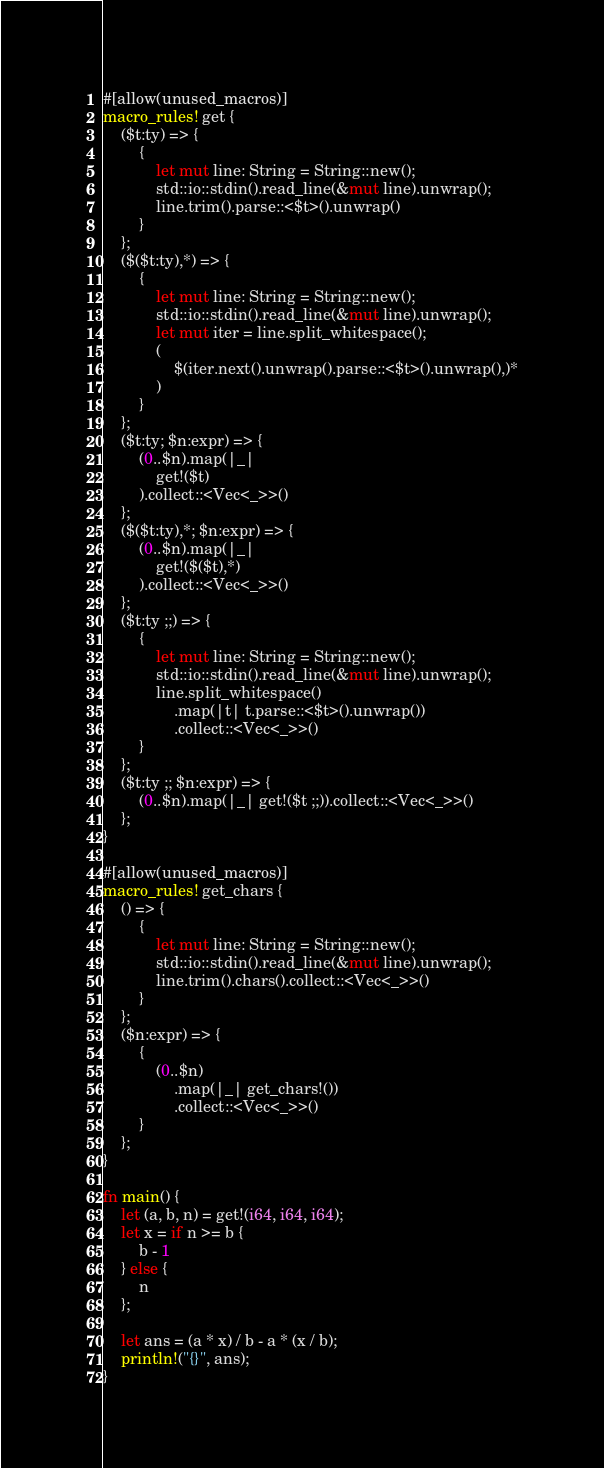<code> <loc_0><loc_0><loc_500><loc_500><_Rust_>#[allow(unused_macros)]
macro_rules! get {
    ($t:ty) => {
        {
            let mut line: String = String::new();
            std::io::stdin().read_line(&mut line).unwrap();
            line.trim().parse::<$t>().unwrap()
        }
    };
    ($($t:ty),*) => {
        {
            let mut line: String = String::new();
            std::io::stdin().read_line(&mut line).unwrap();
            let mut iter = line.split_whitespace();
            (
                $(iter.next().unwrap().parse::<$t>().unwrap(),)*
            )
        }
    };
    ($t:ty; $n:expr) => {
        (0..$n).map(|_|
            get!($t)
        ).collect::<Vec<_>>()
    };
    ($($t:ty),*; $n:expr) => {
        (0..$n).map(|_|
            get!($($t),*)
        ).collect::<Vec<_>>()
    };
    ($t:ty ;;) => {
        {
            let mut line: String = String::new();
            std::io::stdin().read_line(&mut line).unwrap();
            line.split_whitespace()
                .map(|t| t.parse::<$t>().unwrap())
                .collect::<Vec<_>>()
        }
    };
    ($t:ty ;; $n:expr) => {
        (0..$n).map(|_| get!($t ;;)).collect::<Vec<_>>()
    };
}

#[allow(unused_macros)]
macro_rules! get_chars {
    () => {
        {
            let mut line: String = String::new();
            std::io::stdin().read_line(&mut line).unwrap();
            line.trim().chars().collect::<Vec<_>>()
        }
    };
    ($n:expr) => {
        {
            (0..$n)
                .map(|_| get_chars!())
                .collect::<Vec<_>>()
        }
    };
}

fn main() {
    let (a, b, n) = get!(i64, i64, i64);
    let x = if n >= b {
        b - 1
    } else {
        n
    };

    let ans = (a * x) / b - a * (x / b);
    println!("{}", ans);
}
</code> 